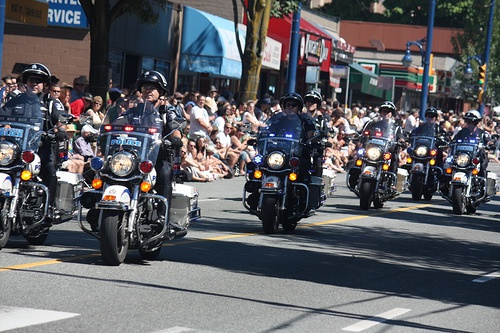Describe the objects in this image and their specific colors. I can see people in darkblue, black, gray, lightgray, and darkgray tones, motorcycle in darkblue, black, gray, white, and darkgray tones, motorcycle in darkblue, black, navy, and gray tones, motorcycle in darkblue, black, gray, and white tones, and people in darkblue, black, gray, and darkgray tones in this image. 